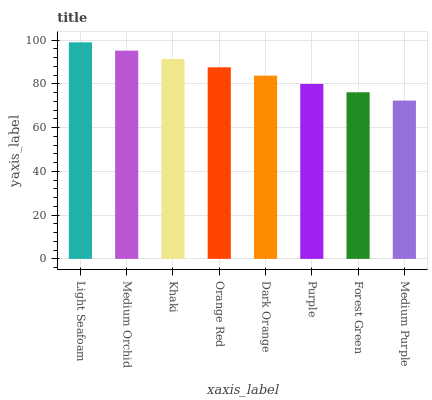Is Medium Purple the minimum?
Answer yes or no. Yes. Is Light Seafoam the maximum?
Answer yes or no. Yes. Is Medium Orchid the minimum?
Answer yes or no. No. Is Medium Orchid the maximum?
Answer yes or no. No. Is Light Seafoam greater than Medium Orchid?
Answer yes or no. Yes. Is Medium Orchid less than Light Seafoam?
Answer yes or no. Yes. Is Medium Orchid greater than Light Seafoam?
Answer yes or no. No. Is Light Seafoam less than Medium Orchid?
Answer yes or no. No. Is Orange Red the high median?
Answer yes or no. Yes. Is Dark Orange the low median?
Answer yes or no. Yes. Is Khaki the high median?
Answer yes or no. No. Is Medium Orchid the low median?
Answer yes or no. No. 